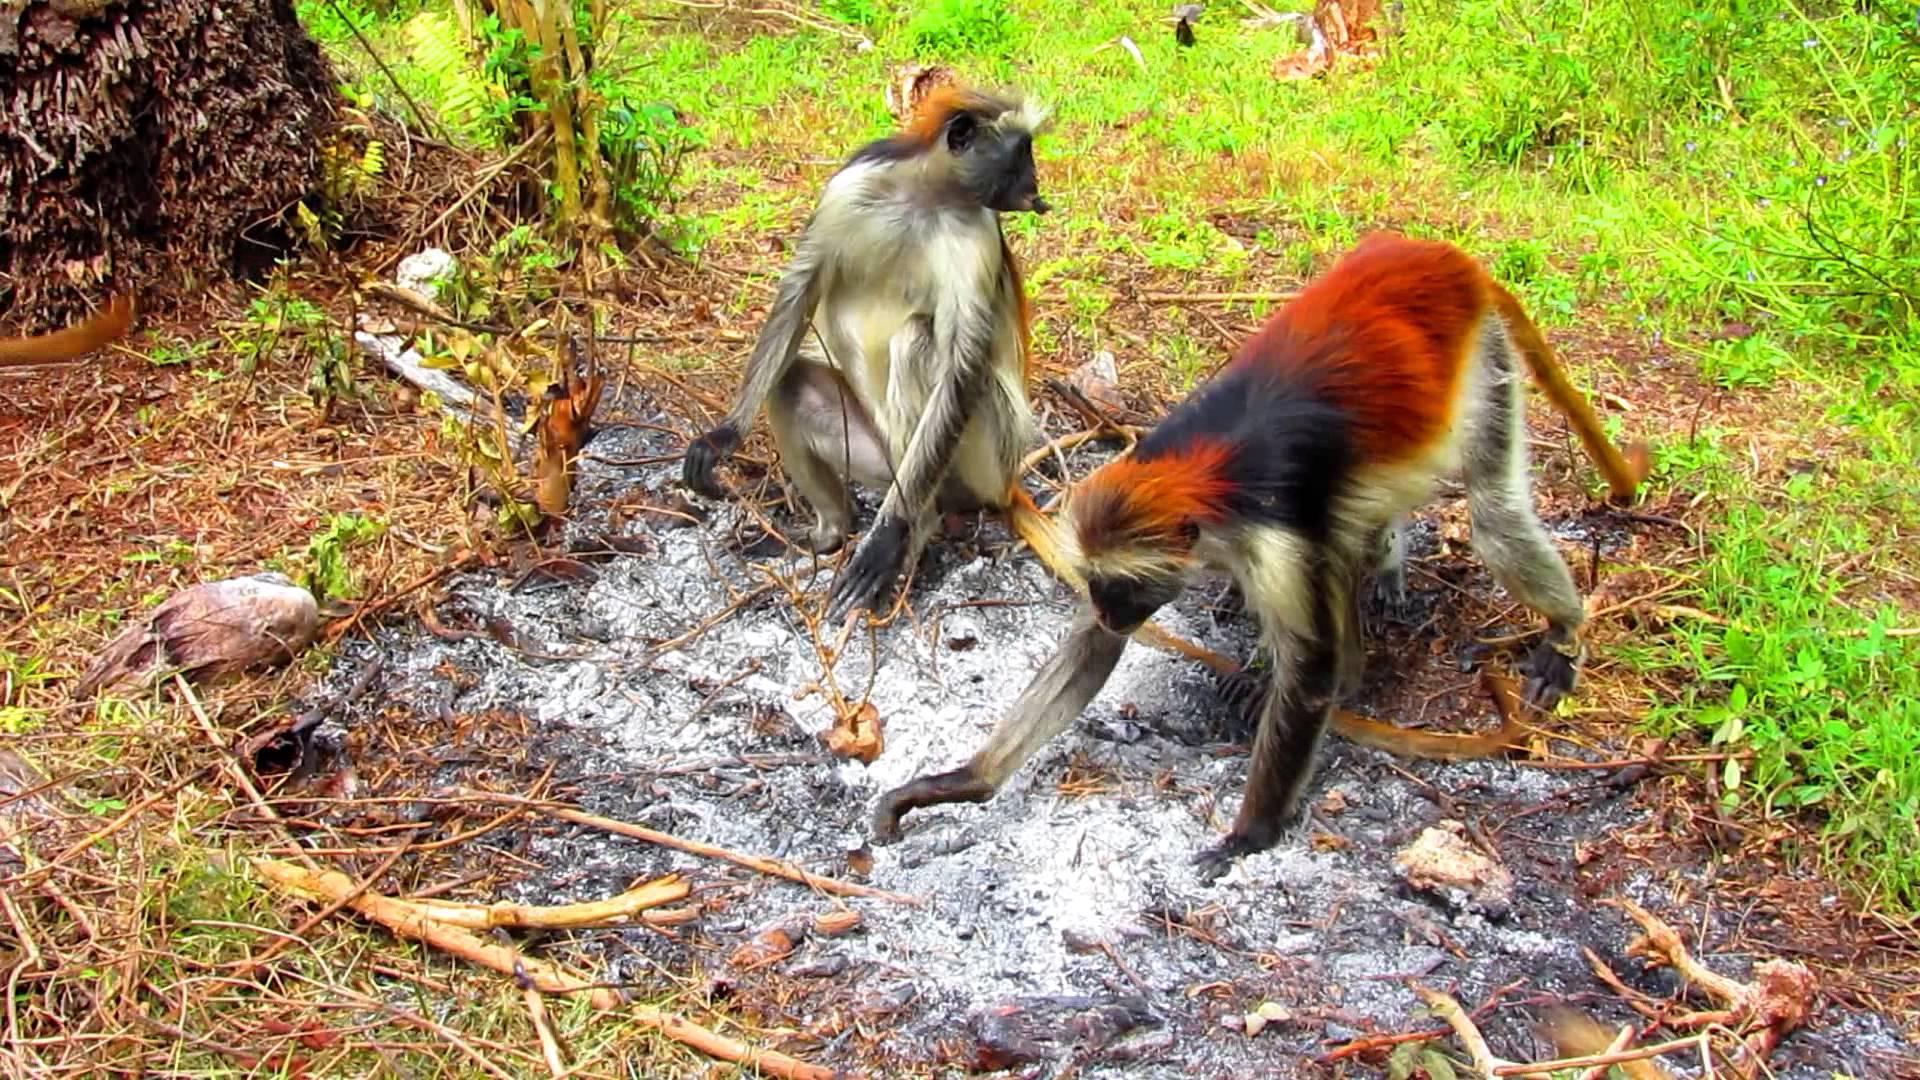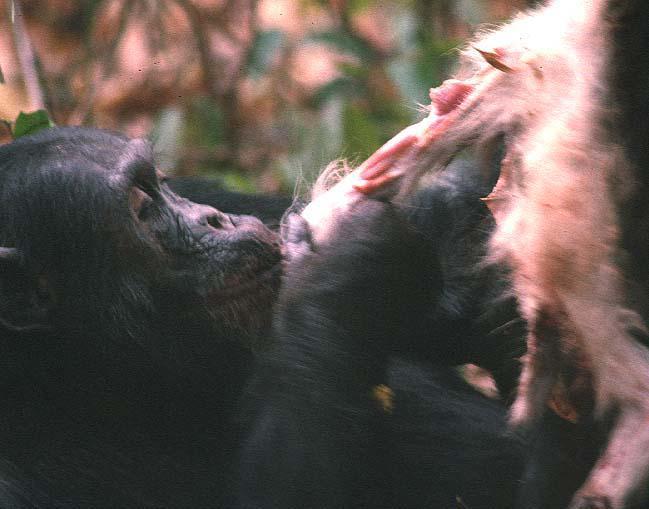The first image is the image on the left, the second image is the image on the right. Considering the images on both sides, is "A group of monkeys is eating meat in one of the images." valid? Answer yes or no. No. The first image is the image on the left, the second image is the image on the right. For the images displayed, is the sentence "An image shows at least three chimps huddled around a piece of carcass." factually correct? Answer yes or no. No. 